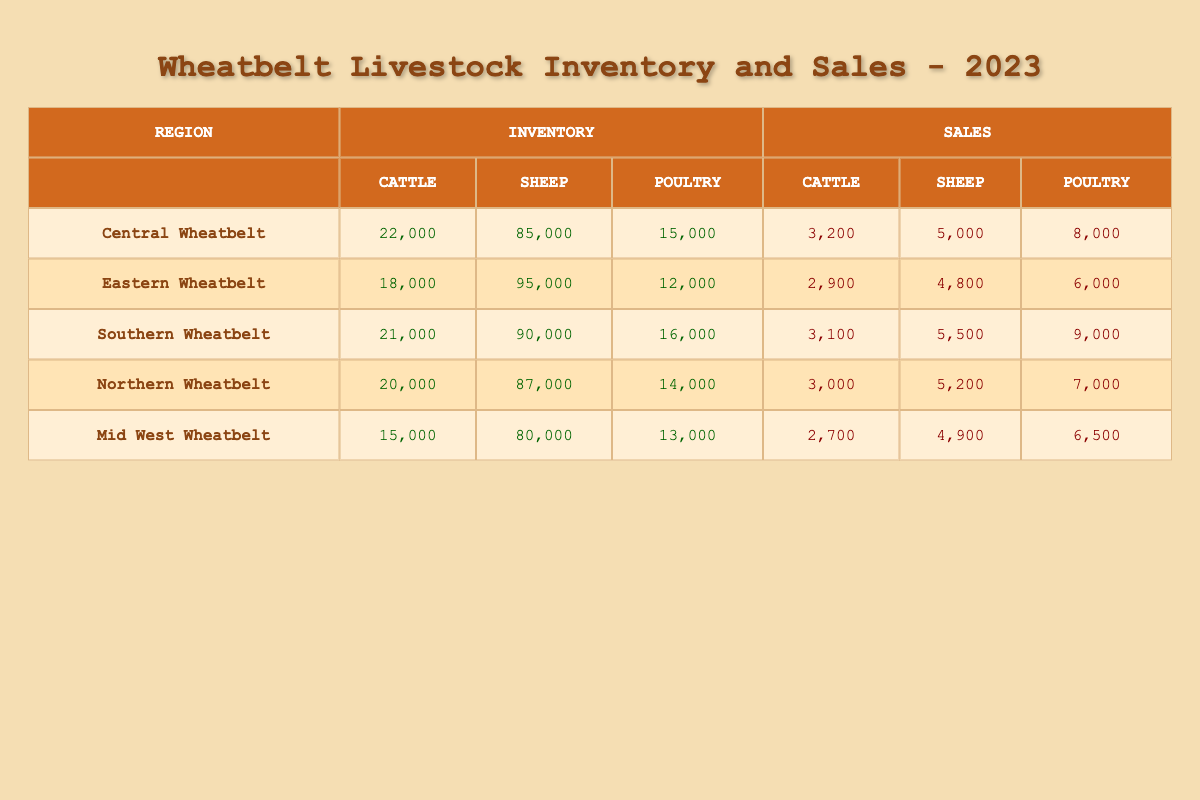What is the total cattle inventory in the Wheatbelt regions? To find the total cattle inventory, add the cattle inventory from all regions: Central Wheatbelt (22000) + Eastern Wheatbelt (18000) + Southern Wheatbelt (21000) + Northern Wheatbelt (20000) + Mid West Wheatbelt (15000) = 116000.
Answer: 116000 Which region has the highest sheep sales? By comparing the sheep sales across regions, Southern Wheatbelt has the highest sheep sales with 5500, compared to the others: Central (5000), Eastern (4800), Northern (5200), and Mid West (4900).
Answer: Southern Wheatbelt What is the inventory difference between cattle and poultry in the Mid West Wheatbelt? To find the difference, subtract the poultry inventory (13000) from the cattle inventory (15000) in the Mid West: 15000 - 13000 = 2000.
Answer: 2000 Is the cattle sales figure higher in Central Wheatbelt than in Northern Wheatbelt? Comparing the cattle sales, Central Wheatbelt has 3200 while Northern Wheatbelt has 3000. Since 3200 is greater than 3000, the statement is true.
Answer: Yes What is the average sheep inventory among all Wheatbelt regions? To calculate the average sheep inventory, add all sheep inventories: Central (85000) + Eastern (95000) + Southern (90000) + Northern (87000) + Mid West (80000) = 437000. Then divide by the number of regions (5): 437000 / 5 = 87400.
Answer: 87400 How many more poultry were sold in Southern Wheatbelt compared to Eastern Wheatbelt? To determine the difference, take the poultry sales in Southern Wheatbelt (9000) and subtract the poultry sales in Eastern Wheatbelt (6000): 9000 - 6000 = 3000.
Answer: 3000 Which region has the least number of cattle, and how many does it have? By checking the cattle inventory across regions, Mid West Wheatbelt has the least number of cattle with 15000.
Answer: Mid West Wheatbelt, 15000 What is the total number of poultry in all regions combined? To find the total poultry inventory, add the poultry inventory from each region: Central (15000) + Eastern (12000) + Southern (16000) + Northern (14000) + Mid West (13000) = 80000.
Answer: 80000 Which region has both the highest cattle inventory and the highest cattle sales? Looking at the data, Central Wheatbelt has the highest cattle inventory (22000) and also the highest cattle sales (3200). No other region exceeds these values.
Answer: Central Wheatbelt What is the total sheep inventory across all regions? To calculate the total sheep inventory, sum the sheep inventories: Central (85000) + Eastern (95000) + Southern (90000) + Northern (87000) + Mid West (80000) = 437000.
Answer: 437000 